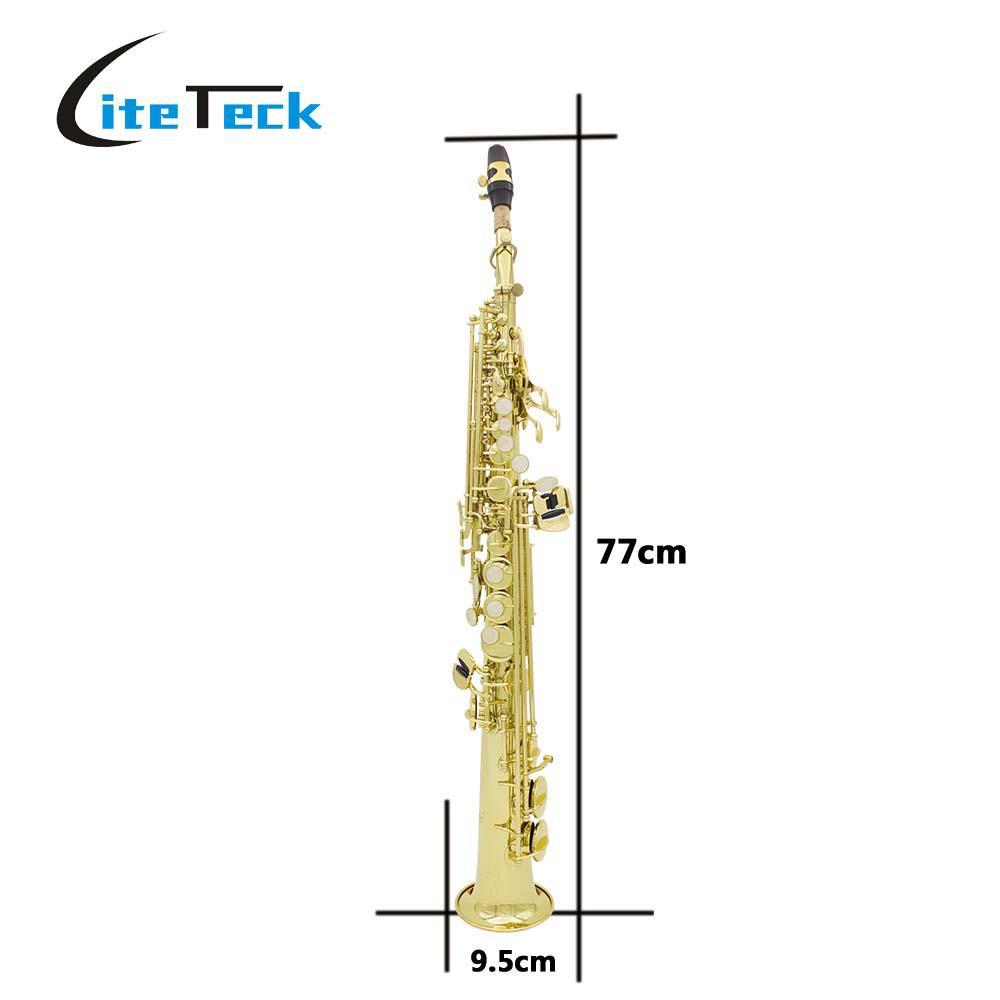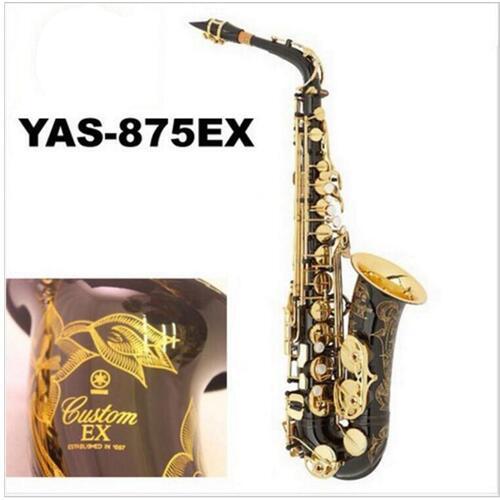The first image is the image on the left, the second image is the image on the right. For the images displayed, is the sentence "One image shows only a straight wind instrument, which is brass colored and does not have an upturned bell." factually correct? Answer yes or no. Yes. 